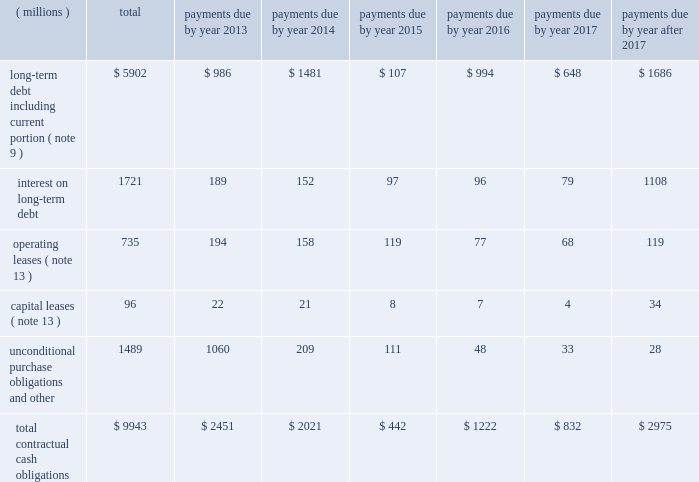Japanese yen ( approximately $ 63 million and $ 188 million , respectively , based on applicable exchange rates at that time ) .
The cash paid of approximately $ 63 million during the quarter ended march 31 , 2010 as a result of the purchase of sumitomo 3m shares from sei is classified as 201cother financing activities 201d in the consolidated statement of cash flows .
The remainder of the purchase financed by the note payable to sei is considered non-cash financing activity in the first quarter of 2010 .
As discussed in note 2 , during the second quarter of 2010 , 3m recorded a financed liability of 1.7 billion japanese yen ( approximately $ 18 million based on applicable exchange rates at that time ) related to the a-one acquisition , which is also considered a non-cash financing activity .
Off-balance sheet arrangements and contractual obligations : as of december 31 , 2012 , the company has not utilized special purpose entities to facilitate off-balance sheet financing arrangements .
Refer to the section entitled 201cwarranties/guarantees 201d in note 13 for discussion of accrued product warranty liabilities and guarantees .
In addition to guarantees , 3m , in the normal course of business , periodically enters into agreements that require the company to indemnify either major customers or suppliers for specific risks , such as claims for injury or property damage arising out of the use of 3m products or the negligence of 3m personnel , or claims alleging that 3m products infringe third- party patents or other intellectual property .
While 3m 2019s maximum exposure under these indemnification provisions cannot be estimated , these indemnifications are not expected to have a material impact on the company 2019s consolidated results of operations or financial condition .
A summary of the company 2019s significant contractual obligations as of december 31 , 2012 , follows : contractual obligations .
Long-term debt payments due in 2013 and 2014 include floating rate notes totaling $ 132 million ( classified as current portion of long-term debt ) and $ 97 million , respectively , as a result of put provisions associated with these debt instruments .
Unconditional purchase obligations are defined as an agreement to purchase goods or services that is enforceable and legally binding on the company .
Included in the unconditional purchase obligations category above are certain obligations related to take or pay contracts , capital commitments , service agreements and utilities .
These estimates include both unconditional purchase obligations with terms in excess of one year and normal ongoing purchase obligations with terms of less than one year .
Many of these commitments relate to take or pay contracts , in which 3m guarantees payment to ensure availability of products or services that are sold to customers .
The company expects to receive consideration ( products or services ) for these unconditional purchase obligations .
Contractual capital commitments are included in the preceding table , but these commitments represent a small part of the company 2019s expected capital spending in 2013 and beyond .
The purchase obligation amounts do not represent the entire anticipated purchases in the future , but represent only those items for which the company is contractually obligated .
The majority of 3m 2019s products and services are purchased as needed , with no unconditional commitment .
For this reason , these amounts will not provide a reliable indicator of the company 2019s expected future cash outflows on a stand-alone basis .
Other obligations , included in the preceding table within the caption entitled 201cunconditional purchase obligations and other , 201d include the current portion of the liability for uncertain tax positions under asc 740 , which is expected to be paid out in cash in the next 12 months .
The company is not able to reasonably estimate the timing of the long-term payments or the amount by which the liability will increase or decrease over time ; therefore , the long-term portion of the net tax liability of $ 170 million is excluded from the preceding table .
Refer to note 7 for further details. .
What was the ratio of the floating rate notes included in the long-term debt payments for 2013 to 2014? 
Rationale: in 2013 there was $ 1.36 of floating rate notes included in the long-term debt payments compared to 2014
Computations: (132 / 97)
Answer: 1.36082. 